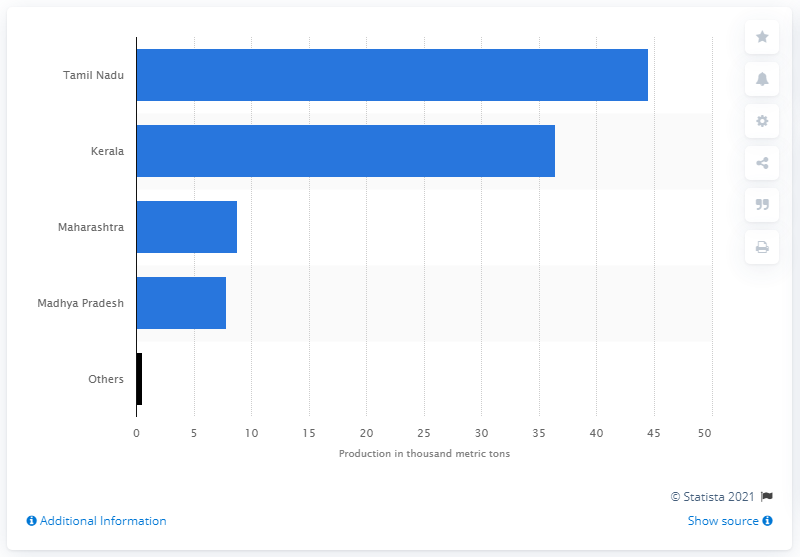Identify some key points in this picture. According to the data from fiscal year 2018, Tamil Nadu was the state that produced the largest volume of tamarind in India. In 2018, the state of Maharashtra ranked third in tamarind production. 